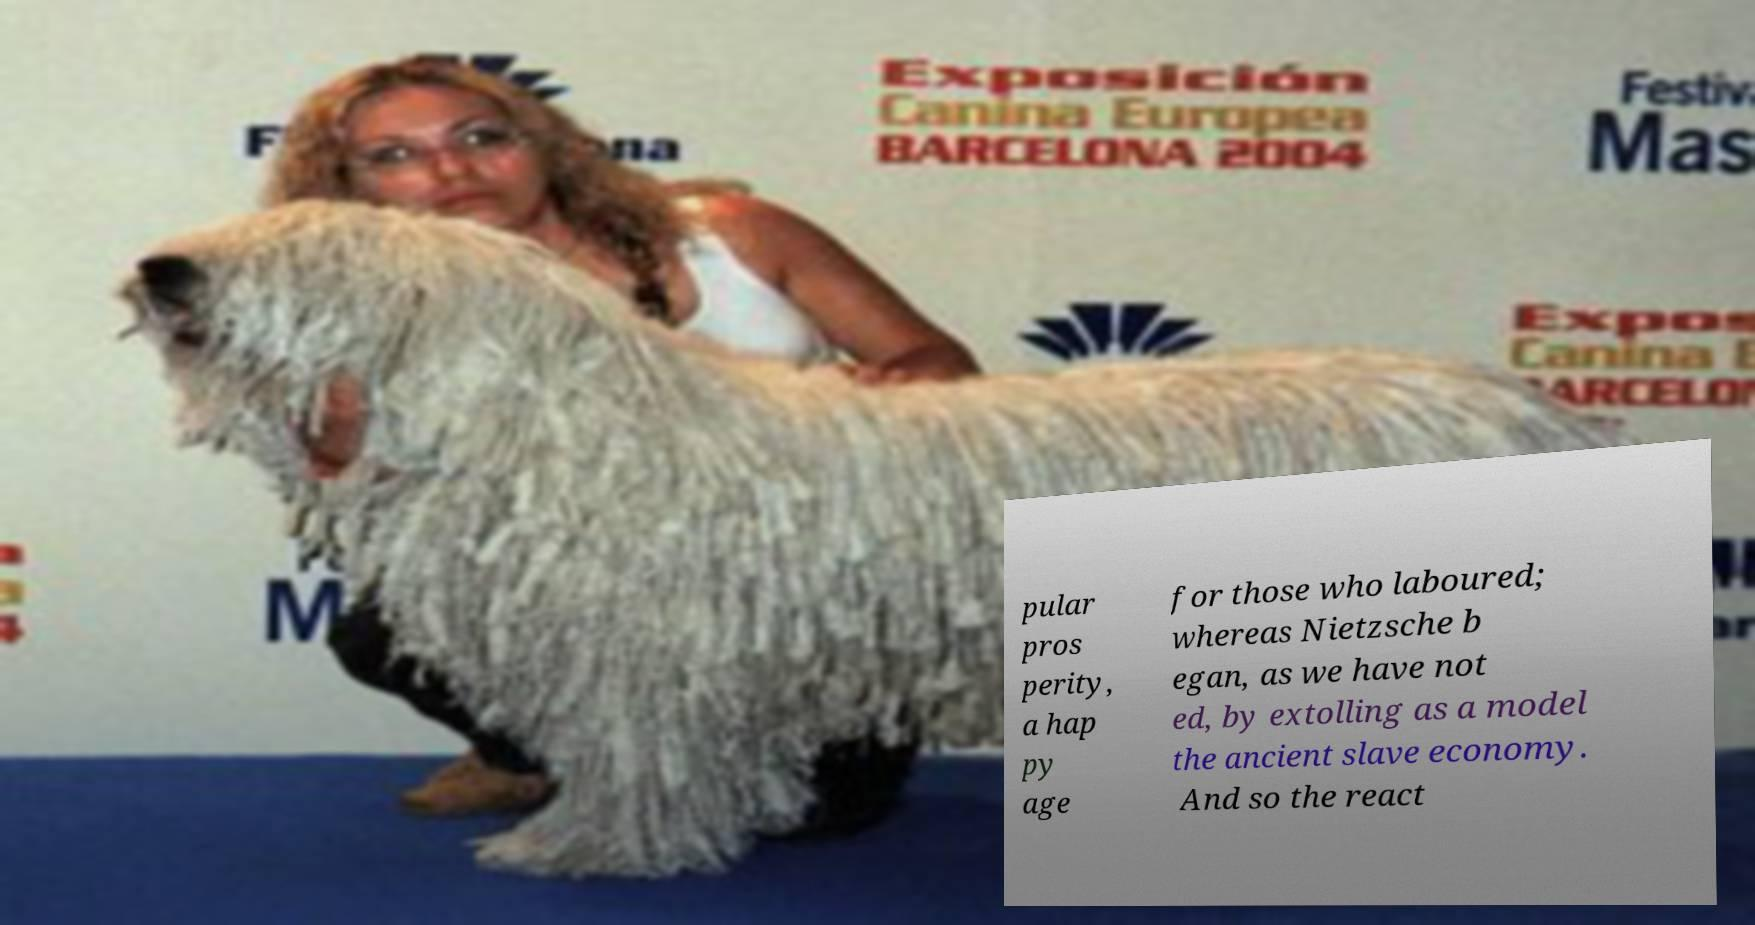What messages or text are displayed in this image? I need them in a readable, typed format. pular pros perity, a hap py age for those who laboured; whereas Nietzsche b egan, as we have not ed, by extolling as a model the ancient slave economy. And so the react 